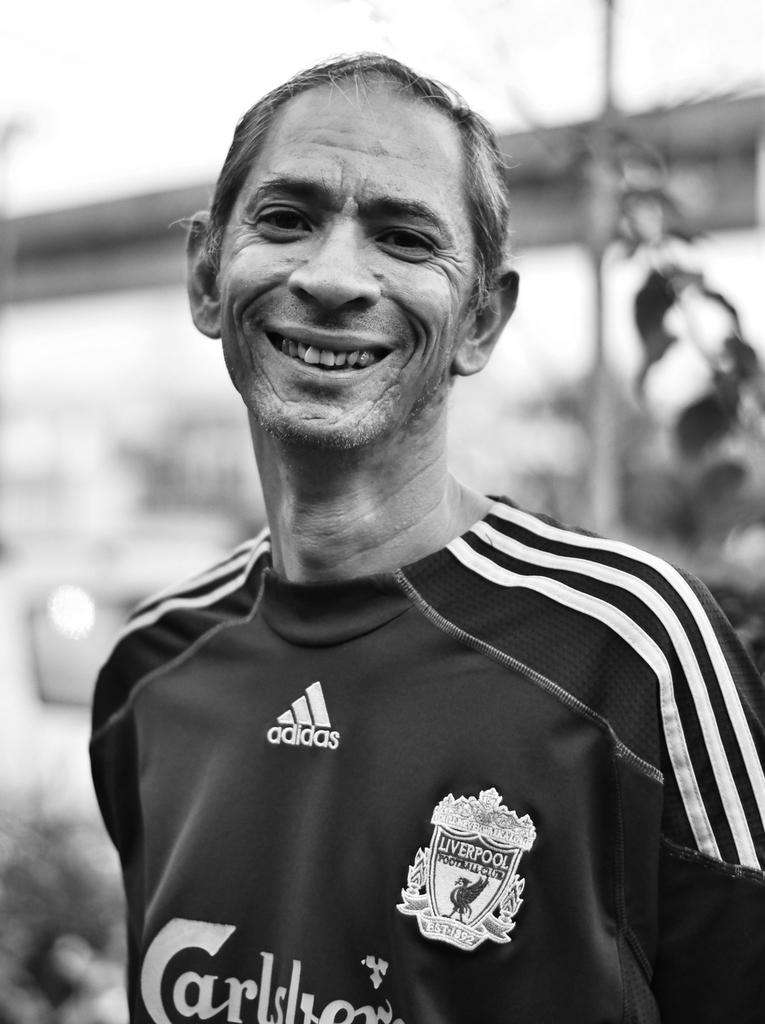<image>
Summarize the visual content of the image. Man wearing a soccer jersey that says Adidas on it. 